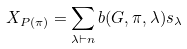<formula> <loc_0><loc_0><loc_500><loc_500>X _ { P ( \pi ) } = \sum _ { \lambda \vdash n } b ( G , \pi , \lambda ) s _ { \lambda }</formula> 